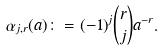Convert formula to latex. <formula><loc_0><loc_0><loc_500><loc_500>\alpha _ { j , r } ( a ) \colon = ( - 1 ) ^ { j } \binom { r } { j } a ^ { - r } .</formula> 